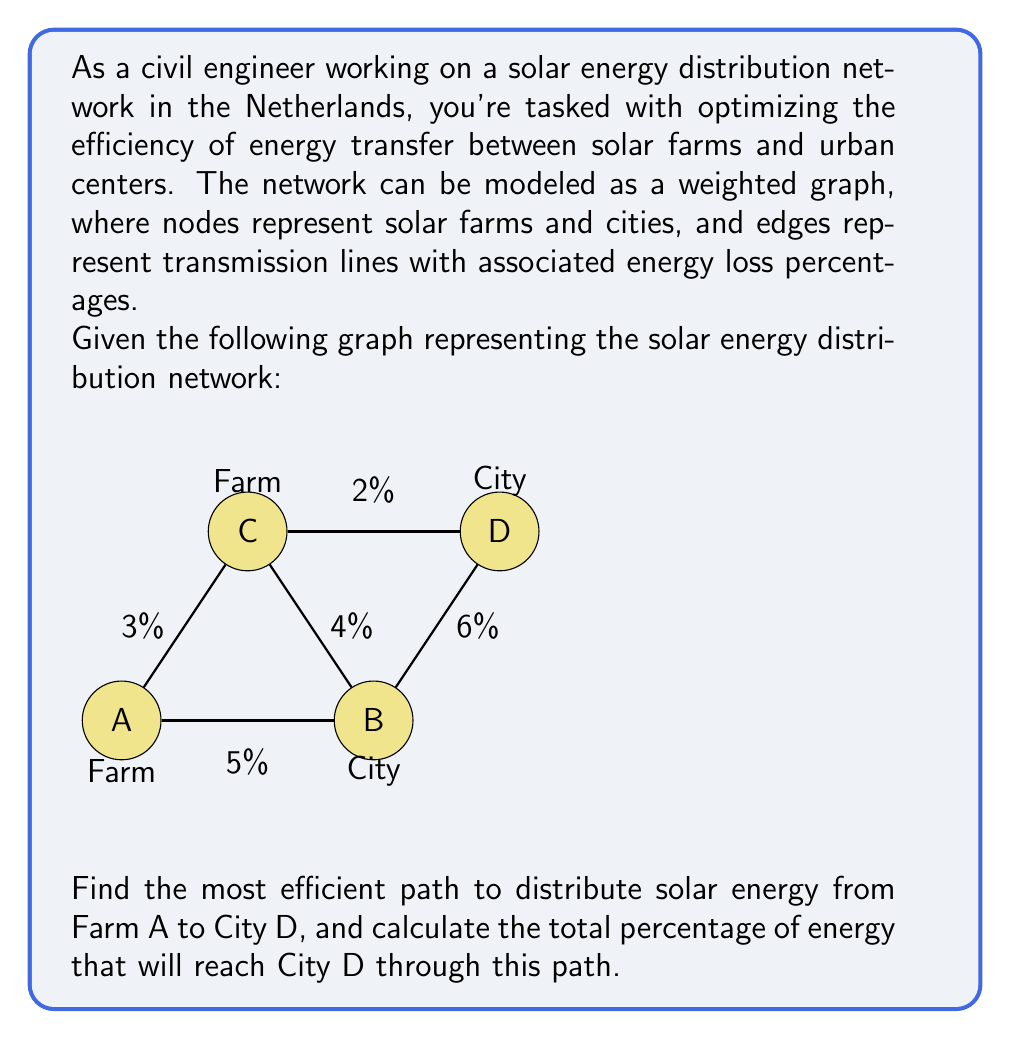Show me your answer to this math problem. To solve this problem, we'll use Dijkstra's algorithm to find the path with the least total energy loss. We'll treat the energy loss percentages as edge weights.

Step 1: Initialize distances
Set distance to A as 0 and all other nodes as infinity.
$d(A) = 0$, $d(B) = d(C) = d(D) = \infty$

Step 2: Visit node A
Update neighbors:
$d(B) = 5\%$
$d(C) = 3\%$

Step 3: Visit node C (closest unvisited node)
Update neighbors:
$d(B) = \min(5\%, 3\% + 4\%) = 5\%$
$d(D) = 3\% + 2\% = 5\%$

Step 4: Visit node B
No updates needed

Step 5: Visit node D
Algorithm complete

The shortest path is A → C → D with a total loss of 5%.

To calculate the energy that reaches D:
Let $x$ be the initial energy at A.
Energy at C = $x \cdot (1 - 0.03) = 0.97x$
Energy at D = $0.97x \cdot (1 - 0.02) = 0.9506x$

Therefore, 95.06% of the energy from A reaches D.
Answer: Path: A → C → D; 95.06% energy reaches D 